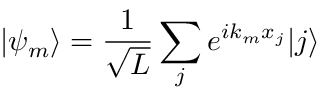Convert formula to latex. <formula><loc_0><loc_0><loc_500><loc_500>| \psi _ { m } \rangle = \frac { 1 } { \sqrt { L } } \sum _ { j } e ^ { i k _ { m } x _ { j } } | j \rangle</formula> 